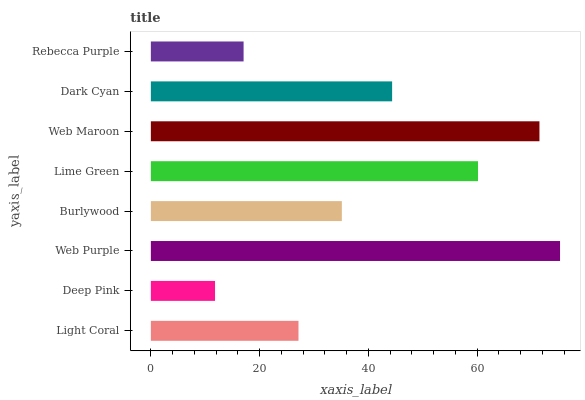Is Deep Pink the minimum?
Answer yes or no. Yes. Is Web Purple the maximum?
Answer yes or no. Yes. Is Web Purple the minimum?
Answer yes or no. No. Is Deep Pink the maximum?
Answer yes or no. No. Is Web Purple greater than Deep Pink?
Answer yes or no. Yes. Is Deep Pink less than Web Purple?
Answer yes or no. Yes. Is Deep Pink greater than Web Purple?
Answer yes or no. No. Is Web Purple less than Deep Pink?
Answer yes or no. No. Is Dark Cyan the high median?
Answer yes or no. Yes. Is Burlywood the low median?
Answer yes or no. Yes. Is Light Coral the high median?
Answer yes or no. No. Is Light Coral the low median?
Answer yes or no. No. 